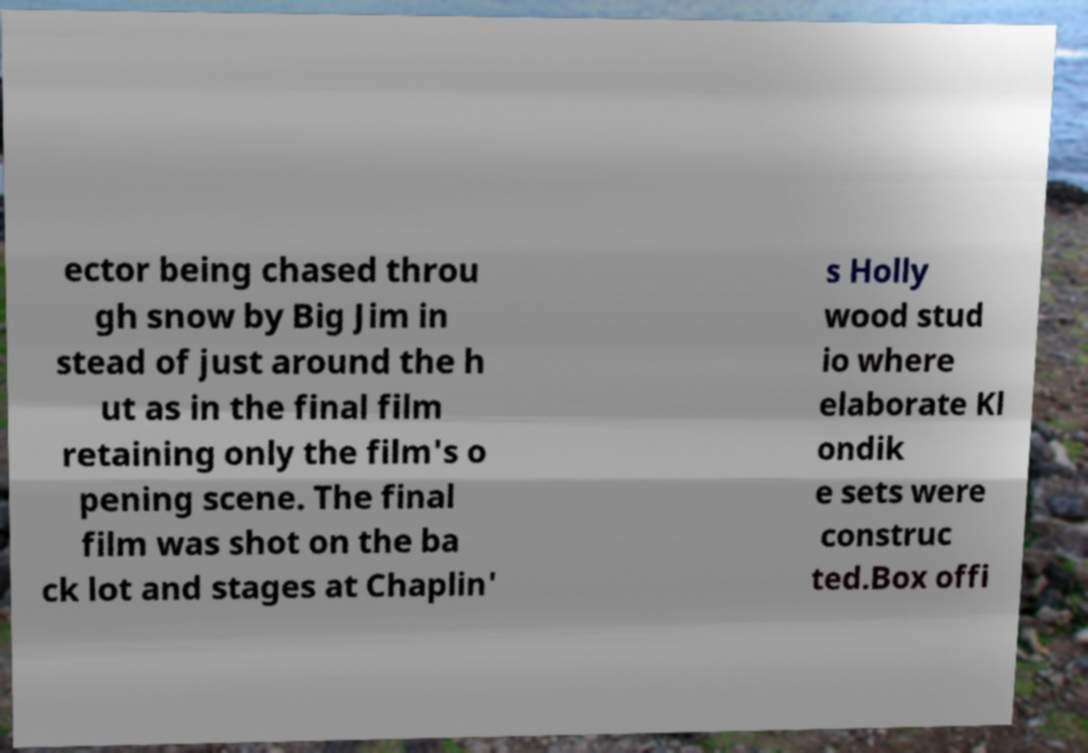Could you assist in decoding the text presented in this image and type it out clearly? ector being chased throu gh snow by Big Jim in stead of just around the h ut as in the final film retaining only the film's o pening scene. The final film was shot on the ba ck lot and stages at Chaplin' s Holly wood stud io where elaborate Kl ondik e sets were construc ted.Box offi 